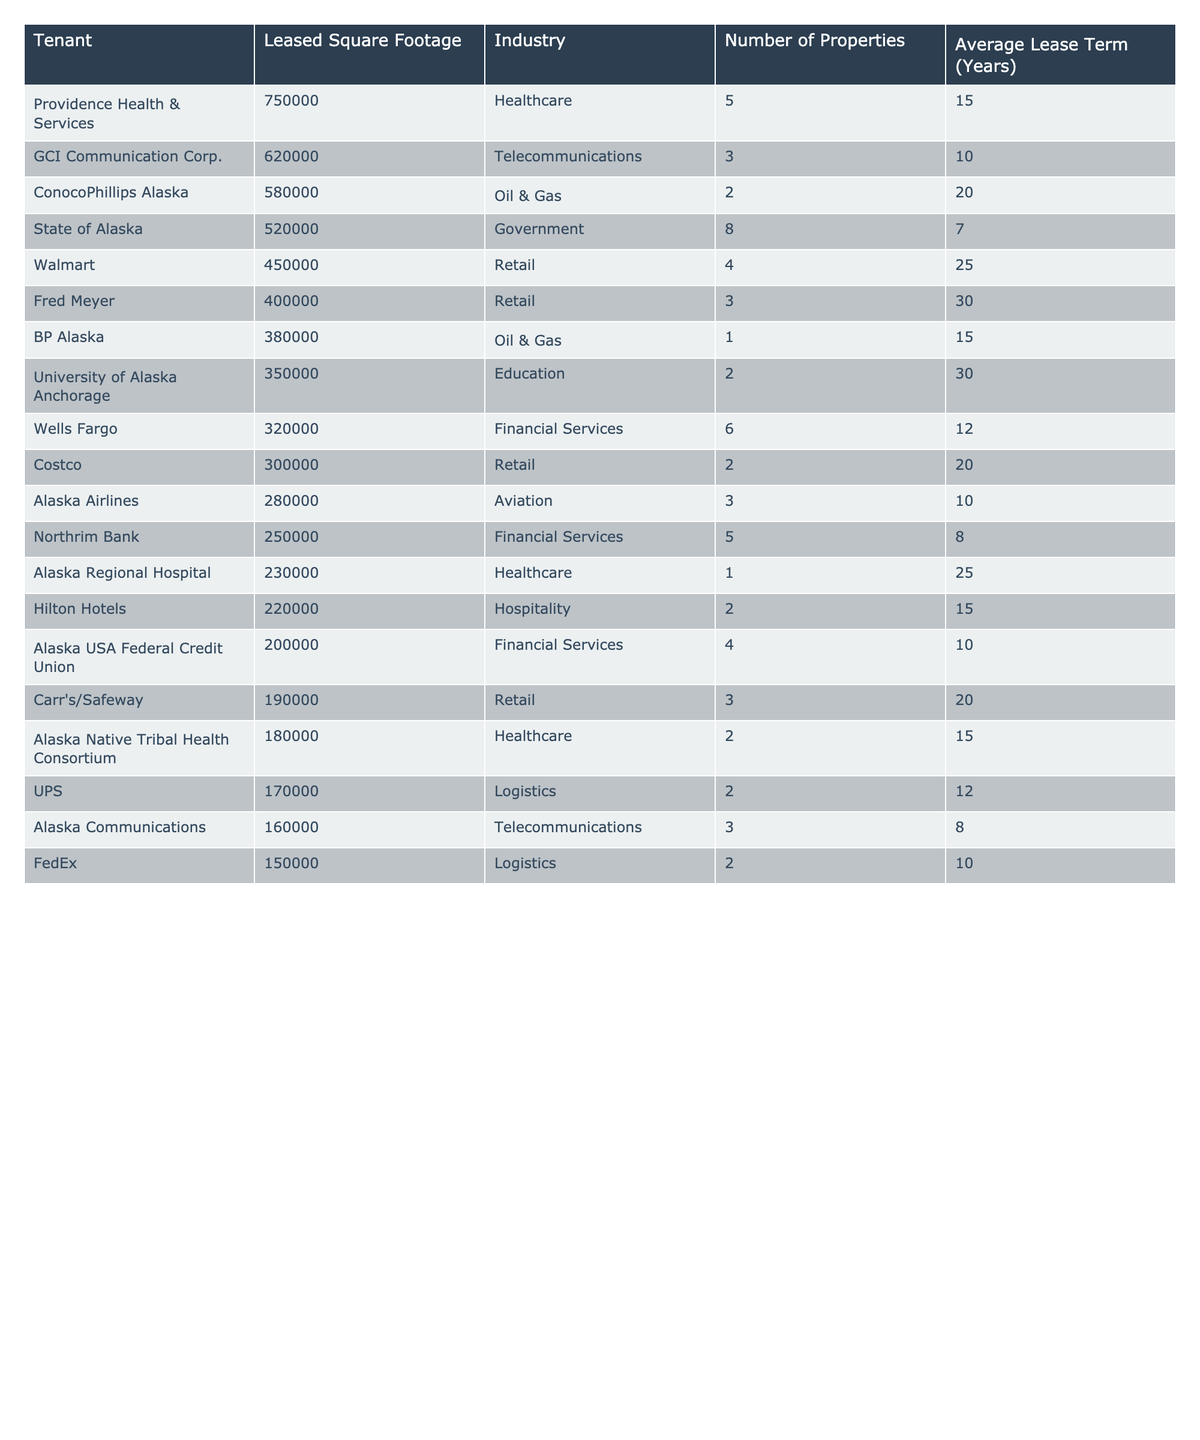What is the total leased square footage for all tenants in the table? By adding the leased square footage of all tenants: 750000 + 620000 + 580000 + 520000 + 450000 + 400000 + 380000 + 350000 + 320000 + 300000 + 280000 + 250000 + 230000 + 220000 + 200000 + 190000 + 180000 + 170000 + 160000 + 150000 =  5750000.
Answer: 5750000 Which tenant has the largest total leased square footage? By examining the values in the "Leased Square Footage" column, the largest value is 750000, corresponding to Providence Health & Services.
Answer: Providence Health & Services How many tenants belong to the Healthcare industry? Count the number of rows where the "Industry" is Healthcare. There are 4 entries: Providence Health & Services, Alaska Regional Hospital, and Alaska Native Tribal Health Consortium.
Answer: 4 What is the average lease term across all tenants? To find the average lease term, sum all the lease terms: (15 + 10 + 20 + 7 + 25 + 30 + 15 + 30 + 12 + 20 + 10 + 8 + 25 + 15 + 10 + 20 + 15 + 12 + 8 + 10) =  400 and divide by 20 (the number of tenants), giving 400 / 20 = 20.
Answer: 20 Is Alaska Airlines the only tenant in the Aviation industry? Check the "Industry" column for "Aviation." It is the only entry listed, confirming there are no others.
Answer: Yes Which industry has the highest number of tenants? Count the number of tenants in each industry: Retail (5), Healthcare (4), Financial Services (4), Oil & Gas (2), Telecommunications (2), Logistics (2), Government (1), Education (1), and Hospitality (1). Retail has the highest number with 5 tenants.
Answer: Retail What is the total leased square footage of the top three tenants? Add the leased square footage of the top three tenants: 750000 (Providence) + 620000 (GCI) + 580000 (ConocoPhillips) = 1950000.
Answer: 1950000 Is the average leased square footage of the "Government" industry higher than that of the "Retail" industry? The average leased square footage of Government is 520000 based on 8 properties, while for Retail it is (450000 + 400000 + 350000 + 190000) / 5 = 388000, which is lower.
Answer: Yes How many properties does Walmart occupy? We can see that in the "Number of Properties" column for Walmart, it states 4.
Answer: 4 What percentage of the total leased square footage does the tenant with the least leased square footage represent? The tenant with the least leased square footage is FedEx with 150000. The percentage is (150000 / 5750000) * 100 = 2.61%.
Answer: 2.61% 